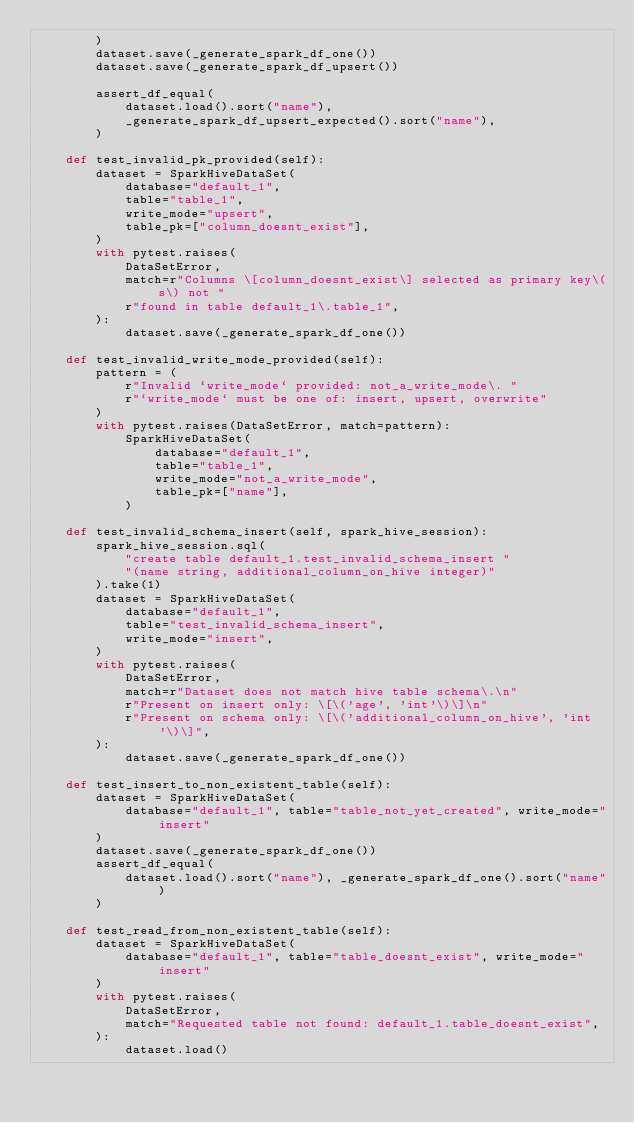Convert code to text. <code><loc_0><loc_0><loc_500><loc_500><_Python_>        )
        dataset.save(_generate_spark_df_one())
        dataset.save(_generate_spark_df_upsert())

        assert_df_equal(
            dataset.load().sort("name"),
            _generate_spark_df_upsert_expected().sort("name"),
        )

    def test_invalid_pk_provided(self):
        dataset = SparkHiveDataSet(
            database="default_1",
            table="table_1",
            write_mode="upsert",
            table_pk=["column_doesnt_exist"],
        )
        with pytest.raises(
            DataSetError,
            match=r"Columns \[column_doesnt_exist\] selected as primary key\(s\) not "
            r"found in table default_1\.table_1",
        ):
            dataset.save(_generate_spark_df_one())

    def test_invalid_write_mode_provided(self):
        pattern = (
            r"Invalid `write_mode` provided: not_a_write_mode\. "
            r"`write_mode` must be one of: insert, upsert, overwrite"
        )
        with pytest.raises(DataSetError, match=pattern):
            SparkHiveDataSet(
                database="default_1",
                table="table_1",
                write_mode="not_a_write_mode",
                table_pk=["name"],
            )

    def test_invalid_schema_insert(self, spark_hive_session):
        spark_hive_session.sql(
            "create table default_1.test_invalid_schema_insert "
            "(name string, additional_column_on_hive integer)"
        ).take(1)
        dataset = SparkHiveDataSet(
            database="default_1",
            table="test_invalid_schema_insert",
            write_mode="insert",
        )
        with pytest.raises(
            DataSetError,
            match=r"Dataset does not match hive table schema\.\n"
            r"Present on insert only: \[\('age', 'int'\)\]\n"
            r"Present on schema only: \[\('additional_column_on_hive', 'int'\)\]",
        ):
            dataset.save(_generate_spark_df_one())

    def test_insert_to_non_existent_table(self):
        dataset = SparkHiveDataSet(
            database="default_1", table="table_not_yet_created", write_mode="insert"
        )
        dataset.save(_generate_spark_df_one())
        assert_df_equal(
            dataset.load().sort("name"), _generate_spark_df_one().sort("name")
        )

    def test_read_from_non_existent_table(self):
        dataset = SparkHiveDataSet(
            database="default_1", table="table_doesnt_exist", write_mode="insert"
        )
        with pytest.raises(
            DataSetError,
            match="Requested table not found: default_1.table_doesnt_exist",
        ):
            dataset.load()
</code> 